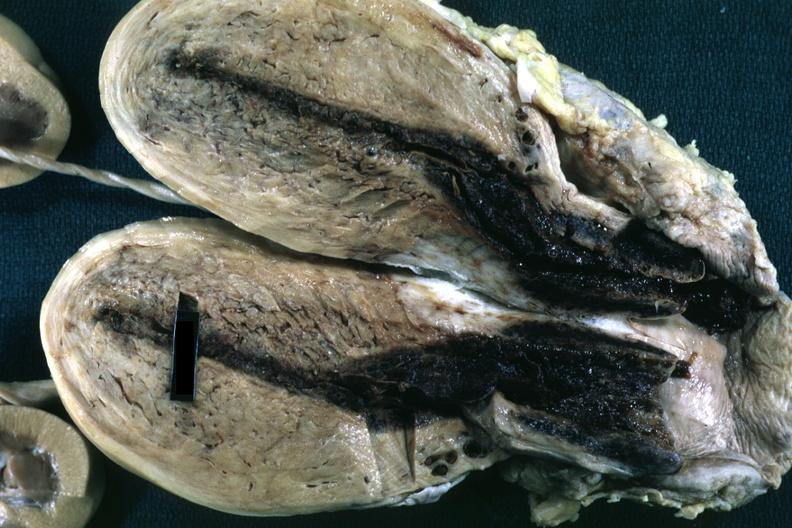does this image show fixed tissue opened uterus with blood clot in cervical canal and small endometrial cavity?
Answer the question using a single word or phrase. Yes 